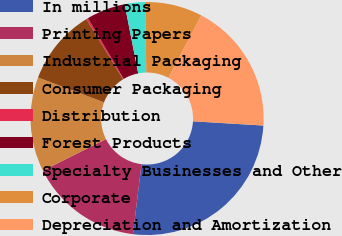<chart> <loc_0><loc_0><loc_500><loc_500><pie_chart><fcel>In millions<fcel>Printing Papers<fcel>Industrial Packaging<fcel>Consumer Packaging<fcel>Distribution<fcel>Forest Products<fcel>Specialty Businesses and Other<fcel>Corporate<fcel>Depreciation and Amortization<nl><fcel>25.98%<fcel>15.69%<fcel>13.11%<fcel>10.54%<fcel>0.25%<fcel>5.39%<fcel>2.82%<fcel>7.97%<fcel>18.26%<nl></chart> 